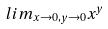Convert formula to latex. <formula><loc_0><loc_0><loc_500><loc_500>l i m _ { x \rightarrow 0 , y \rightarrow 0 } x ^ { y }</formula> 